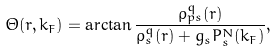<formula> <loc_0><loc_0><loc_500><loc_500>\Theta ( r , k _ { F } ) = \arctan \frac { \rho _ { p s } ^ { q } ( r ) } { \rho _ { s } ^ { q } ( r ) + g _ { s } P _ { s } ^ { N } ( k _ { F } ) } ,</formula> 